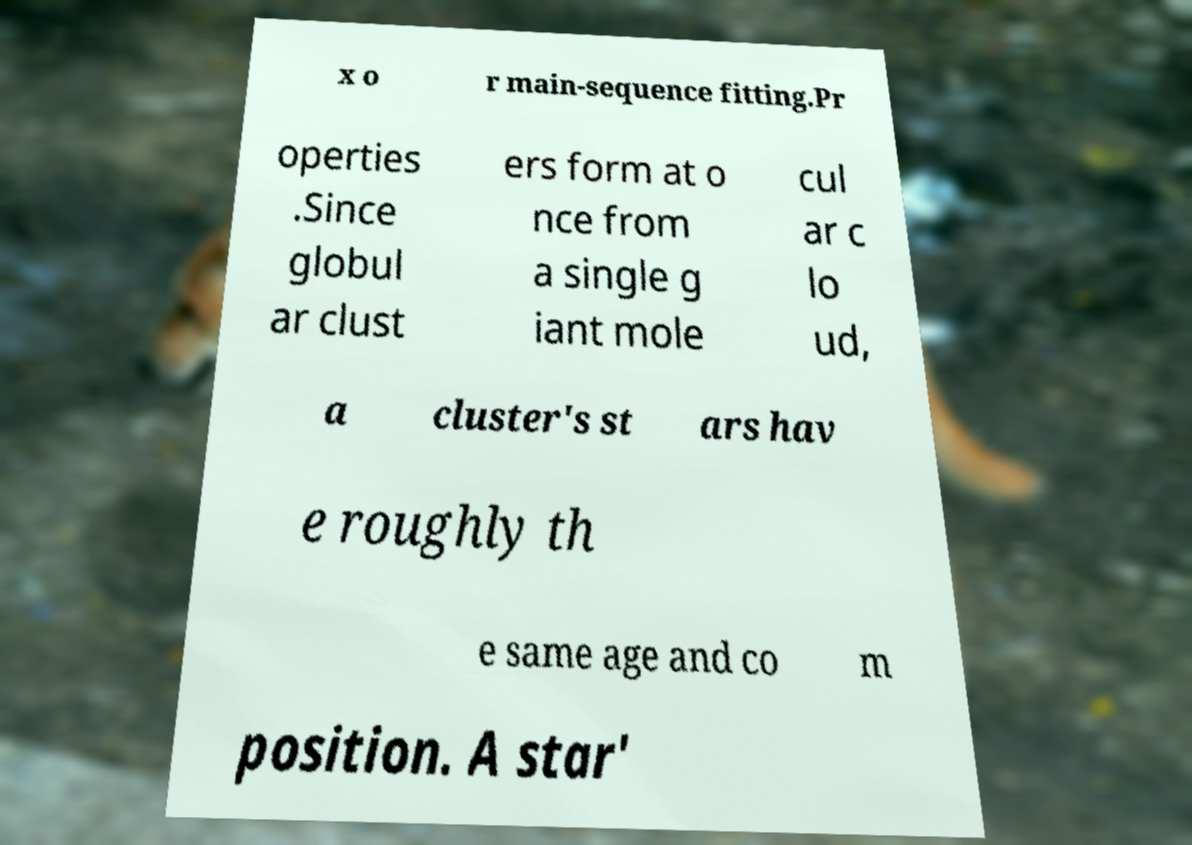What messages or text are displayed in this image? I need them in a readable, typed format. x o r main-sequence fitting.Pr operties .Since globul ar clust ers form at o nce from a single g iant mole cul ar c lo ud, a cluster's st ars hav e roughly th e same age and co m position. A star' 